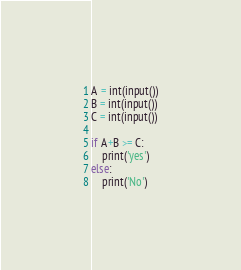<code> <loc_0><loc_0><loc_500><loc_500><_Python_>A = int(input())
B = int(input())
C = int(input())

if A+B >= C:
    print('yes')
else:
    print('No')</code> 